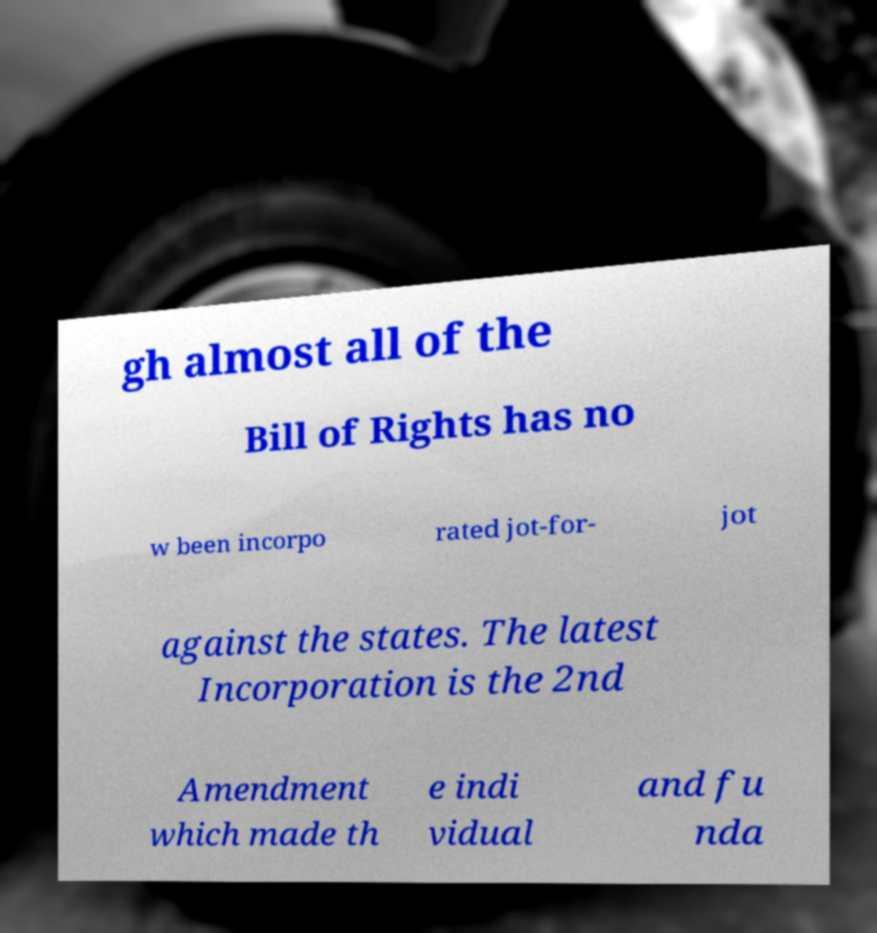Could you extract and type out the text from this image? gh almost all of the Bill of Rights has no w been incorpo rated jot-for- jot against the states. The latest Incorporation is the 2nd Amendment which made th e indi vidual and fu nda 